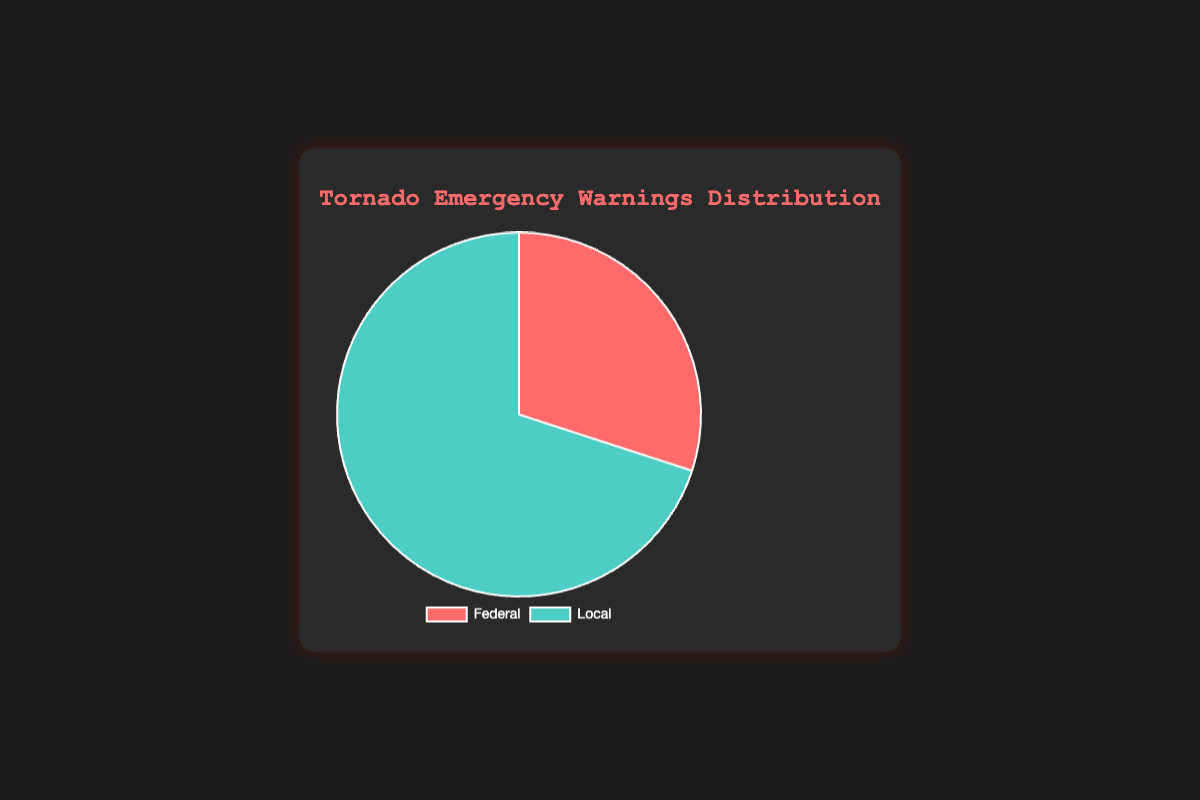Which authority has issued more tornado emergency warnings, Federal or Local? By looking at the sizes of the slices in the pie chart, the Local authority has a larger slice compared to the Federal authority. Therefore, the Local authority has issued more warnings.
Answer: Local What is the total number of tornado emergency warnings issued by both authorities? To find the total number of warnings, add the counts issued by the Federal and Local authorities: 180 (Federal) + 420 (Local) = 600 warnings.
Answer: 600 What percentage of the total warnings are issued by the Local authority? To find the percentage, divide the count of warnings issued by the Local authority by the total number of warnings and multiply by 100: (420 / 600) * 100 ≈ 70%.
Answer: 70% What percentage of the total warnings are issued by the Federal authority? To find the percentage, divide the count of warnings issued by the Federal authority by the total number of warnings and multiply by 100: (180 / 600) * 100 = 30%.
Answer: 30% How many more warnings does the Local authority issue compared to the Federal authority? To find how many more warnings the Local authority issued, subtract the count of Federal warnings from the count of Local warnings: 420 - 180 = 240 warnings.
Answer: 240 If another 50 warnings were issued by the Federal authority, how would the total number of tornado warnings change? Adding 50 more warnings to the Federal authority's count: 180 + 50 = 230 warnings. Then, the new total number of warnings is 230 (Federal) + 420 (Local) = 650 warnings.
Answer: 650 What is the ratio of Local to Federal warnings? The ratio is calculated by dividing the count of Local warnings by the count of Federal warnings: 420 / 180 = 2.33.
Answer: 2.33 Between the two authorities, which one uses turquoise color in the pie chart? By looking at the visual attributes, the Local authority’s slice is turquoise.
Answer: Local 